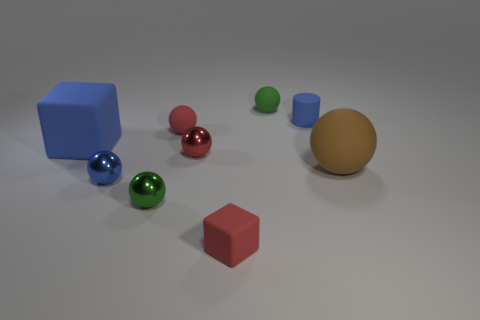What is the material of the ball that is the same color as the small matte cylinder?
Provide a succinct answer. Metal. Is there any other thing that is the same shape as the tiny blue rubber object?
Your response must be concise. No. Is the large cube the same color as the tiny cylinder?
Provide a short and direct response. Yes. What number of other things are there of the same color as the small matte cylinder?
Your answer should be compact. 2. The big rubber thing that is the same shape as the tiny red metal thing is what color?
Ensure brevity in your answer.  Brown. How many large objects are on the right side of the blue matte block and on the left side of the small matte cube?
Keep it short and to the point. 0. Is the number of tiny things behind the small red rubber ball greater than the number of rubber cubes that are to the left of the tiny cube?
Provide a short and direct response. Yes. What is the size of the red block?
Make the answer very short. Small. Is there another big brown thing of the same shape as the brown object?
Your answer should be very brief. No. Is the shape of the tiny green matte thing the same as the tiny metallic object that is in front of the tiny blue metal sphere?
Ensure brevity in your answer.  Yes. 